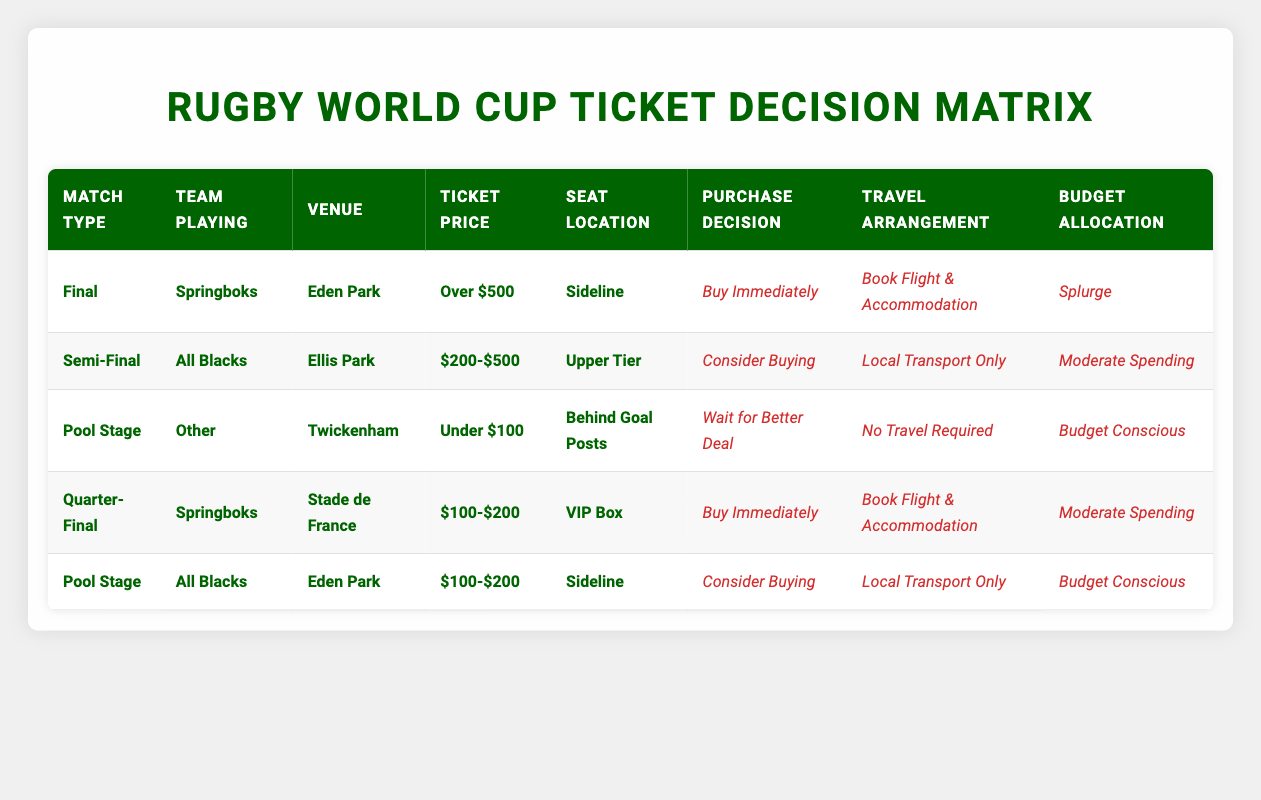What is the recommended purchase decision for a Final match with the Springboks at Eden Park? The table indicates that if the match type is "Final," the team playing is "Springboks," and it's at "Eden Park" with a ticket price of "Over $500" and seat location "Sideline," the action is to "Buy Immediately."
Answer: Buy Immediately For a Semi-Final match at Ellis Park involving All Blacks, what is the budget allocation? According to the table, for a "Semi-Final" match with "All Blacks" at "Ellis Park" where the ticket price is "$200-$500" and seat location is "Upper Tier," the budget allocation is "Moderate Spending."
Answer: Moderate Spending Is there a recommendation to wait for a better deal for the Pool Stage match featuring Other teams at Twickenham? The table shows that for a "Pool Stage" match with "Other" at "Twickenham," ticket price "Under $100," and seat location "Behind Goal Posts," the action is to "Wait for Better Deal."
Answer: Yes What travel arrangement is suggested for attending a Quarter-Final match with Springboks at Stade de France in the VIP Box? The relevant entry states that for a "Quarter-Final" with "Springboks" at "Stade de France," ticket price "$100-$200," and seat location "VIP Box," the suggested travel arrangement is to "Book Flight & Accommodation."
Answer: Book Flight & Accommodation If a fan is looking to support the All Blacks during a Pool Stage match at Eden Park, should they expect to make a significant budget allocation? The table lists the action for a "Pool Stage" match with "All Blacks" at "Eden Park," costing "$100-$200" and seat location "Sideline" as "Consider Buying," with the budget allocation as "Budget Conscious," indicating that significant spending is not expected.
Answer: No What are the actions if someone is attending the Final match at Eden Park for over $500? The table outlines that for the "Final" at "Eden Park" with a ticket price of "Over $500," the recommended actions are "Buy Immediately," "Book Flight & Accommodation," and "Splurge."
Answer: Buy Immediately, Book Flight & Accommodation, Splurge How many matches in the table involve the Springboks team, and what are the purchase decisions? There are two matches featuring the Springboks listed in the table: one is the "Final" with a decision to "Buy Immediately," and the other is a "Quarter-Final," also recommending to "Buy Immediately." Therefore, both matches align in recommending immediate purchase.
Answer: 2 matches, Buy Immediately, Buy Immediately What is the most expensive ticket option available in the table? The most expensive ticket option listed in the table is "Over $500" for the "Final" match with "Springboks" at "Eden Park."
Answer: Over $500 What is the average ticket price for the matches listed in the table? The ticket prices in the entries are: Over $500, $200-$500, Under $100, $100-$200, and $100-$200. To find the average, we need to assign numeric values to these ranges: let's say Over $500 = 600, $200-$500 = 350, Under $100 = 50, $100-$200 = 150, we can use 150 (midpoint). Adding these values gives us 600 + 350 + 50 + 150 + 150 = 1300. To find the average, we divide by the number of matches: 1300 / 5 = 260.
Answer: 260 